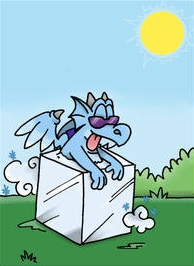Please describe this image as accurately as possible, and make sure to go over every possible detail as well. The image depicts an animated scene with a blue cartoon character, which appears to be a blend between a dragon and a dog, sitting atop a white cube. The dragon-dog creature has a playful expression on its face, with a wide-open mouth showing its tongue, and is wearing dark sunglasses that imply a relaxed or cool attitude. The creature has two wings sprouting from its back and is seated in such a way that one might think it's ready to leap off or has just landed on the cube.

The background illustrates a clear sky with a few clouds and a shining yellow sun at the top right of the image. The ground is represented with a simple green color, suggesting grass, with tiny rounded bushes or shrubs at the bottom edges of the picture. The edges of the cube cast a light gray shadow below it, indicating the source of light coming from the sun. The overall feel of the image is cartoonish and cheerful, designed to be engaging, especially to a younger audience. 